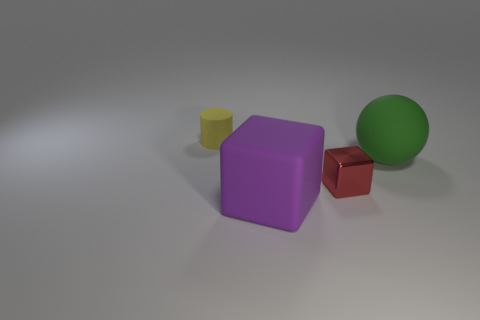Add 2 gray cubes. How many objects exist? 6 Subtract all small brown blocks. Subtract all green objects. How many objects are left? 3 Add 3 big objects. How many big objects are left? 5 Add 3 gray shiny cylinders. How many gray shiny cylinders exist? 3 Subtract 0 brown cubes. How many objects are left? 4 